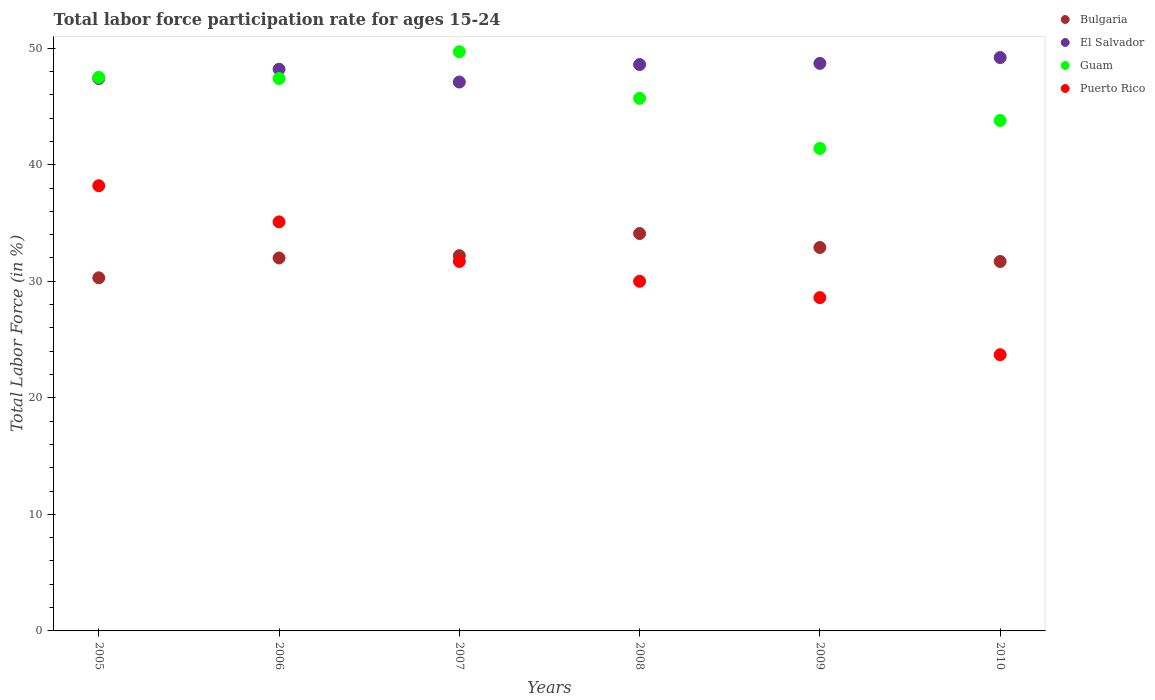How many different coloured dotlines are there?
Provide a succinct answer. 4. Across all years, what is the maximum labor force participation rate in Bulgaria?
Offer a terse response. 34.1. Across all years, what is the minimum labor force participation rate in El Salvador?
Your response must be concise. 47.1. In which year was the labor force participation rate in Bulgaria maximum?
Ensure brevity in your answer.  2008. In which year was the labor force participation rate in El Salvador minimum?
Your answer should be very brief. 2007. What is the total labor force participation rate in Bulgaria in the graph?
Provide a short and direct response. 193.2. What is the difference between the labor force participation rate in Guam in 2006 and that in 2007?
Your answer should be compact. -2.3. What is the difference between the labor force participation rate in Puerto Rico in 2010 and the labor force participation rate in Bulgaria in 2007?
Provide a short and direct response. -8.5. What is the average labor force participation rate in Puerto Rico per year?
Your answer should be very brief. 31.22. In the year 2005, what is the difference between the labor force participation rate in Bulgaria and labor force participation rate in El Salvador?
Make the answer very short. -17.1. In how many years, is the labor force participation rate in El Salvador greater than 16 %?
Your response must be concise. 6. What is the ratio of the labor force participation rate in Guam in 2006 to that in 2010?
Keep it short and to the point. 1.08. Is the labor force participation rate in Puerto Rico in 2007 less than that in 2009?
Your answer should be compact. No. Is the difference between the labor force participation rate in Bulgaria in 2005 and 2006 greater than the difference between the labor force participation rate in El Salvador in 2005 and 2006?
Offer a terse response. No. What is the difference between the highest and the second highest labor force participation rate in El Salvador?
Provide a short and direct response. 0.5. What is the difference between the highest and the lowest labor force participation rate in Guam?
Offer a terse response. 8.3. In how many years, is the labor force participation rate in Puerto Rico greater than the average labor force participation rate in Puerto Rico taken over all years?
Provide a short and direct response. 3. Is the sum of the labor force participation rate in El Salvador in 2008 and 2010 greater than the maximum labor force participation rate in Guam across all years?
Provide a succinct answer. Yes. Is it the case that in every year, the sum of the labor force participation rate in Puerto Rico and labor force participation rate in Guam  is greater than the sum of labor force participation rate in Bulgaria and labor force participation rate in El Salvador?
Your answer should be compact. No. Is it the case that in every year, the sum of the labor force participation rate in Guam and labor force participation rate in Puerto Rico  is greater than the labor force participation rate in Bulgaria?
Offer a terse response. Yes. Is the labor force participation rate in Puerto Rico strictly less than the labor force participation rate in Bulgaria over the years?
Your response must be concise. No. How many dotlines are there?
Your answer should be very brief. 4. What is the difference between two consecutive major ticks on the Y-axis?
Keep it short and to the point. 10. Does the graph contain any zero values?
Provide a succinct answer. No. Does the graph contain grids?
Your answer should be compact. No. What is the title of the graph?
Provide a succinct answer. Total labor force participation rate for ages 15-24. Does "Georgia" appear as one of the legend labels in the graph?
Give a very brief answer. No. What is the label or title of the X-axis?
Provide a short and direct response. Years. What is the label or title of the Y-axis?
Your answer should be very brief. Total Labor Force (in %). What is the Total Labor Force (in %) in Bulgaria in 2005?
Provide a succinct answer. 30.3. What is the Total Labor Force (in %) in El Salvador in 2005?
Offer a very short reply. 47.4. What is the Total Labor Force (in %) of Guam in 2005?
Provide a succinct answer. 47.5. What is the Total Labor Force (in %) in Puerto Rico in 2005?
Offer a very short reply. 38.2. What is the Total Labor Force (in %) of Bulgaria in 2006?
Provide a short and direct response. 32. What is the Total Labor Force (in %) of El Salvador in 2006?
Your response must be concise. 48.2. What is the Total Labor Force (in %) of Guam in 2006?
Give a very brief answer. 47.4. What is the Total Labor Force (in %) in Puerto Rico in 2006?
Give a very brief answer. 35.1. What is the Total Labor Force (in %) in Bulgaria in 2007?
Offer a very short reply. 32.2. What is the Total Labor Force (in %) in El Salvador in 2007?
Make the answer very short. 47.1. What is the Total Labor Force (in %) of Guam in 2007?
Ensure brevity in your answer.  49.7. What is the Total Labor Force (in %) of Puerto Rico in 2007?
Make the answer very short. 31.7. What is the Total Labor Force (in %) in Bulgaria in 2008?
Offer a terse response. 34.1. What is the Total Labor Force (in %) in El Salvador in 2008?
Your answer should be very brief. 48.6. What is the Total Labor Force (in %) of Guam in 2008?
Your answer should be very brief. 45.7. What is the Total Labor Force (in %) in Bulgaria in 2009?
Provide a succinct answer. 32.9. What is the Total Labor Force (in %) of El Salvador in 2009?
Keep it short and to the point. 48.7. What is the Total Labor Force (in %) in Guam in 2009?
Make the answer very short. 41.4. What is the Total Labor Force (in %) in Puerto Rico in 2009?
Your answer should be compact. 28.6. What is the Total Labor Force (in %) of Bulgaria in 2010?
Make the answer very short. 31.7. What is the Total Labor Force (in %) in El Salvador in 2010?
Your response must be concise. 49.2. What is the Total Labor Force (in %) of Guam in 2010?
Offer a very short reply. 43.8. What is the Total Labor Force (in %) in Puerto Rico in 2010?
Your answer should be compact. 23.7. Across all years, what is the maximum Total Labor Force (in %) in Bulgaria?
Your answer should be compact. 34.1. Across all years, what is the maximum Total Labor Force (in %) in El Salvador?
Give a very brief answer. 49.2. Across all years, what is the maximum Total Labor Force (in %) of Guam?
Offer a terse response. 49.7. Across all years, what is the maximum Total Labor Force (in %) of Puerto Rico?
Provide a succinct answer. 38.2. Across all years, what is the minimum Total Labor Force (in %) in Bulgaria?
Provide a short and direct response. 30.3. Across all years, what is the minimum Total Labor Force (in %) of El Salvador?
Keep it short and to the point. 47.1. Across all years, what is the minimum Total Labor Force (in %) in Guam?
Offer a very short reply. 41.4. Across all years, what is the minimum Total Labor Force (in %) of Puerto Rico?
Your answer should be very brief. 23.7. What is the total Total Labor Force (in %) in Bulgaria in the graph?
Offer a very short reply. 193.2. What is the total Total Labor Force (in %) of El Salvador in the graph?
Provide a succinct answer. 289.2. What is the total Total Labor Force (in %) in Guam in the graph?
Give a very brief answer. 275.5. What is the total Total Labor Force (in %) of Puerto Rico in the graph?
Provide a short and direct response. 187.3. What is the difference between the Total Labor Force (in %) of Bulgaria in 2005 and that in 2007?
Provide a succinct answer. -1.9. What is the difference between the Total Labor Force (in %) of Guam in 2005 and that in 2007?
Offer a very short reply. -2.2. What is the difference between the Total Labor Force (in %) in El Salvador in 2005 and that in 2008?
Make the answer very short. -1.2. What is the difference between the Total Labor Force (in %) of Guam in 2005 and that in 2008?
Your answer should be very brief. 1.8. What is the difference between the Total Labor Force (in %) in El Salvador in 2005 and that in 2009?
Your response must be concise. -1.3. What is the difference between the Total Labor Force (in %) of Puerto Rico in 2005 and that in 2009?
Your answer should be compact. 9.6. What is the difference between the Total Labor Force (in %) in Bulgaria in 2005 and that in 2010?
Your response must be concise. -1.4. What is the difference between the Total Labor Force (in %) in Puerto Rico in 2005 and that in 2010?
Give a very brief answer. 14.5. What is the difference between the Total Labor Force (in %) in Bulgaria in 2006 and that in 2007?
Your answer should be compact. -0.2. What is the difference between the Total Labor Force (in %) in Guam in 2006 and that in 2007?
Ensure brevity in your answer.  -2.3. What is the difference between the Total Labor Force (in %) in Puerto Rico in 2006 and that in 2007?
Keep it short and to the point. 3.4. What is the difference between the Total Labor Force (in %) in El Salvador in 2006 and that in 2008?
Make the answer very short. -0.4. What is the difference between the Total Labor Force (in %) in Guam in 2006 and that in 2008?
Make the answer very short. 1.7. What is the difference between the Total Labor Force (in %) in Guam in 2006 and that in 2009?
Provide a succinct answer. 6. What is the difference between the Total Labor Force (in %) in Bulgaria in 2006 and that in 2010?
Your response must be concise. 0.3. What is the difference between the Total Labor Force (in %) in Guam in 2006 and that in 2010?
Ensure brevity in your answer.  3.6. What is the difference between the Total Labor Force (in %) in Puerto Rico in 2006 and that in 2010?
Make the answer very short. 11.4. What is the difference between the Total Labor Force (in %) in Puerto Rico in 2007 and that in 2009?
Give a very brief answer. 3.1. What is the difference between the Total Labor Force (in %) in Guam in 2007 and that in 2010?
Ensure brevity in your answer.  5.9. What is the difference between the Total Labor Force (in %) of Bulgaria in 2008 and that in 2009?
Provide a short and direct response. 1.2. What is the difference between the Total Labor Force (in %) of Guam in 2008 and that in 2009?
Make the answer very short. 4.3. What is the difference between the Total Labor Force (in %) of Guam in 2008 and that in 2010?
Make the answer very short. 1.9. What is the difference between the Total Labor Force (in %) in Puerto Rico in 2008 and that in 2010?
Give a very brief answer. 6.3. What is the difference between the Total Labor Force (in %) of Bulgaria in 2009 and that in 2010?
Offer a very short reply. 1.2. What is the difference between the Total Labor Force (in %) of El Salvador in 2009 and that in 2010?
Offer a very short reply. -0.5. What is the difference between the Total Labor Force (in %) in Guam in 2009 and that in 2010?
Provide a succinct answer. -2.4. What is the difference between the Total Labor Force (in %) of Bulgaria in 2005 and the Total Labor Force (in %) of El Salvador in 2006?
Your answer should be very brief. -17.9. What is the difference between the Total Labor Force (in %) in Bulgaria in 2005 and the Total Labor Force (in %) in Guam in 2006?
Give a very brief answer. -17.1. What is the difference between the Total Labor Force (in %) in El Salvador in 2005 and the Total Labor Force (in %) in Guam in 2006?
Offer a very short reply. 0. What is the difference between the Total Labor Force (in %) in El Salvador in 2005 and the Total Labor Force (in %) in Puerto Rico in 2006?
Offer a very short reply. 12.3. What is the difference between the Total Labor Force (in %) in Guam in 2005 and the Total Labor Force (in %) in Puerto Rico in 2006?
Keep it short and to the point. 12.4. What is the difference between the Total Labor Force (in %) of Bulgaria in 2005 and the Total Labor Force (in %) of El Salvador in 2007?
Provide a short and direct response. -16.8. What is the difference between the Total Labor Force (in %) of Bulgaria in 2005 and the Total Labor Force (in %) of Guam in 2007?
Offer a very short reply. -19.4. What is the difference between the Total Labor Force (in %) of Bulgaria in 2005 and the Total Labor Force (in %) of Puerto Rico in 2007?
Your answer should be very brief. -1.4. What is the difference between the Total Labor Force (in %) in El Salvador in 2005 and the Total Labor Force (in %) in Guam in 2007?
Give a very brief answer. -2.3. What is the difference between the Total Labor Force (in %) of El Salvador in 2005 and the Total Labor Force (in %) of Puerto Rico in 2007?
Your answer should be compact. 15.7. What is the difference between the Total Labor Force (in %) of Guam in 2005 and the Total Labor Force (in %) of Puerto Rico in 2007?
Make the answer very short. 15.8. What is the difference between the Total Labor Force (in %) of Bulgaria in 2005 and the Total Labor Force (in %) of El Salvador in 2008?
Offer a terse response. -18.3. What is the difference between the Total Labor Force (in %) in Bulgaria in 2005 and the Total Labor Force (in %) in Guam in 2008?
Provide a succinct answer. -15.4. What is the difference between the Total Labor Force (in %) in El Salvador in 2005 and the Total Labor Force (in %) in Guam in 2008?
Your answer should be compact. 1.7. What is the difference between the Total Labor Force (in %) in Bulgaria in 2005 and the Total Labor Force (in %) in El Salvador in 2009?
Make the answer very short. -18.4. What is the difference between the Total Labor Force (in %) of Bulgaria in 2005 and the Total Labor Force (in %) of Guam in 2009?
Your answer should be compact. -11.1. What is the difference between the Total Labor Force (in %) of El Salvador in 2005 and the Total Labor Force (in %) of Puerto Rico in 2009?
Keep it short and to the point. 18.8. What is the difference between the Total Labor Force (in %) in Guam in 2005 and the Total Labor Force (in %) in Puerto Rico in 2009?
Offer a terse response. 18.9. What is the difference between the Total Labor Force (in %) of Bulgaria in 2005 and the Total Labor Force (in %) of El Salvador in 2010?
Your response must be concise. -18.9. What is the difference between the Total Labor Force (in %) in Bulgaria in 2005 and the Total Labor Force (in %) in Guam in 2010?
Offer a terse response. -13.5. What is the difference between the Total Labor Force (in %) in Bulgaria in 2005 and the Total Labor Force (in %) in Puerto Rico in 2010?
Make the answer very short. 6.6. What is the difference between the Total Labor Force (in %) of El Salvador in 2005 and the Total Labor Force (in %) of Guam in 2010?
Ensure brevity in your answer.  3.6. What is the difference between the Total Labor Force (in %) in El Salvador in 2005 and the Total Labor Force (in %) in Puerto Rico in 2010?
Your answer should be compact. 23.7. What is the difference between the Total Labor Force (in %) in Guam in 2005 and the Total Labor Force (in %) in Puerto Rico in 2010?
Provide a succinct answer. 23.8. What is the difference between the Total Labor Force (in %) of Bulgaria in 2006 and the Total Labor Force (in %) of El Salvador in 2007?
Offer a very short reply. -15.1. What is the difference between the Total Labor Force (in %) of Bulgaria in 2006 and the Total Labor Force (in %) of Guam in 2007?
Ensure brevity in your answer.  -17.7. What is the difference between the Total Labor Force (in %) in Bulgaria in 2006 and the Total Labor Force (in %) in Puerto Rico in 2007?
Ensure brevity in your answer.  0.3. What is the difference between the Total Labor Force (in %) in El Salvador in 2006 and the Total Labor Force (in %) in Guam in 2007?
Keep it short and to the point. -1.5. What is the difference between the Total Labor Force (in %) of El Salvador in 2006 and the Total Labor Force (in %) of Puerto Rico in 2007?
Provide a short and direct response. 16.5. What is the difference between the Total Labor Force (in %) of Bulgaria in 2006 and the Total Labor Force (in %) of El Salvador in 2008?
Provide a succinct answer. -16.6. What is the difference between the Total Labor Force (in %) in Bulgaria in 2006 and the Total Labor Force (in %) in Guam in 2008?
Keep it short and to the point. -13.7. What is the difference between the Total Labor Force (in %) in Bulgaria in 2006 and the Total Labor Force (in %) in Puerto Rico in 2008?
Offer a very short reply. 2. What is the difference between the Total Labor Force (in %) of El Salvador in 2006 and the Total Labor Force (in %) of Guam in 2008?
Your response must be concise. 2.5. What is the difference between the Total Labor Force (in %) of El Salvador in 2006 and the Total Labor Force (in %) of Puerto Rico in 2008?
Give a very brief answer. 18.2. What is the difference between the Total Labor Force (in %) of Bulgaria in 2006 and the Total Labor Force (in %) of El Salvador in 2009?
Ensure brevity in your answer.  -16.7. What is the difference between the Total Labor Force (in %) in Bulgaria in 2006 and the Total Labor Force (in %) in Guam in 2009?
Your answer should be very brief. -9.4. What is the difference between the Total Labor Force (in %) in Bulgaria in 2006 and the Total Labor Force (in %) in Puerto Rico in 2009?
Keep it short and to the point. 3.4. What is the difference between the Total Labor Force (in %) in El Salvador in 2006 and the Total Labor Force (in %) in Guam in 2009?
Give a very brief answer. 6.8. What is the difference between the Total Labor Force (in %) in El Salvador in 2006 and the Total Labor Force (in %) in Puerto Rico in 2009?
Your response must be concise. 19.6. What is the difference between the Total Labor Force (in %) in Bulgaria in 2006 and the Total Labor Force (in %) in El Salvador in 2010?
Offer a very short reply. -17.2. What is the difference between the Total Labor Force (in %) in Guam in 2006 and the Total Labor Force (in %) in Puerto Rico in 2010?
Provide a short and direct response. 23.7. What is the difference between the Total Labor Force (in %) in Bulgaria in 2007 and the Total Labor Force (in %) in El Salvador in 2008?
Your answer should be very brief. -16.4. What is the difference between the Total Labor Force (in %) in Bulgaria in 2007 and the Total Labor Force (in %) in Puerto Rico in 2008?
Keep it short and to the point. 2.2. What is the difference between the Total Labor Force (in %) in El Salvador in 2007 and the Total Labor Force (in %) in Guam in 2008?
Your answer should be compact. 1.4. What is the difference between the Total Labor Force (in %) in El Salvador in 2007 and the Total Labor Force (in %) in Puerto Rico in 2008?
Make the answer very short. 17.1. What is the difference between the Total Labor Force (in %) of Guam in 2007 and the Total Labor Force (in %) of Puerto Rico in 2008?
Your answer should be compact. 19.7. What is the difference between the Total Labor Force (in %) of Bulgaria in 2007 and the Total Labor Force (in %) of El Salvador in 2009?
Make the answer very short. -16.5. What is the difference between the Total Labor Force (in %) of El Salvador in 2007 and the Total Labor Force (in %) of Puerto Rico in 2009?
Your response must be concise. 18.5. What is the difference between the Total Labor Force (in %) in Guam in 2007 and the Total Labor Force (in %) in Puerto Rico in 2009?
Your answer should be very brief. 21.1. What is the difference between the Total Labor Force (in %) of Bulgaria in 2007 and the Total Labor Force (in %) of El Salvador in 2010?
Your answer should be compact. -17. What is the difference between the Total Labor Force (in %) in Bulgaria in 2007 and the Total Labor Force (in %) in Guam in 2010?
Your answer should be very brief. -11.6. What is the difference between the Total Labor Force (in %) of El Salvador in 2007 and the Total Labor Force (in %) of Guam in 2010?
Offer a very short reply. 3.3. What is the difference between the Total Labor Force (in %) in El Salvador in 2007 and the Total Labor Force (in %) in Puerto Rico in 2010?
Your response must be concise. 23.4. What is the difference between the Total Labor Force (in %) of Bulgaria in 2008 and the Total Labor Force (in %) of El Salvador in 2009?
Make the answer very short. -14.6. What is the difference between the Total Labor Force (in %) of Bulgaria in 2008 and the Total Labor Force (in %) of Guam in 2009?
Your answer should be very brief. -7.3. What is the difference between the Total Labor Force (in %) in Bulgaria in 2008 and the Total Labor Force (in %) in Puerto Rico in 2009?
Your answer should be very brief. 5.5. What is the difference between the Total Labor Force (in %) in Guam in 2008 and the Total Labor Force (in %) in Puerto Rico in 2009?
Your response must be concise. 17.1. What is the difference between the Total Labor Force (in %) in Bulgaria in 2008 and the Total Labor Force (in %) in El Salvador in 2010?
Offer a terse response. -15.1. What is the difference between the Total Labor Force (in %) of El Salvador in 2008 and the Total Labor Force (in %) of Guam in 2010?
Offer a very short reply. 4.8. What is the difference between the Total Labor Force (in %) in El Salvador in 2008 and the Total Labor Force (in %) in Puerto Rico in 2010?
Your answer should be compact. 24.9. What is the difference between the Total Labor Force (in %) of Bulgaria in 2009 and the Total Labor Force (in %) of El Salvador in 2010?
Give a very brief answer. -16.3. What is the difference between the Total Labor Force (in %) of Bulgaria in 2009 and the Total Labor Force (in %) of Puerto Rico in 2010?
Keep it short and to the point. 9.2. What is the difference between the Total Labor Force (in %) in El Salvador in 2009 and the Total Labor Force (in %) in Guam in 2010?
Ensure brevity in your answer.  4.9. What is the difference between the Total Labor Force (in %) in El Salvador in 2009 and the Total Labor Force (in %) in Puerto Rico in 2010?
Keep it short and to the point. 25. What is the average Total Labor Force (in %) of Bulgaria per year?
Provide a short and direct response. 32.2. What is the average Total Labor Force (in %) in El Salvador per year?
Offer a very short reply. 48.2. What is the average Total Labor Force (in %) in Guam per year?
Ensure brevity in your answer.  45.92. What is the average Total Labor Force (in %) in Puerto Rico per year?
Make the answer very short. 31.22. In the year 2005, what is the difference between the Total Labor Force (in %) of Bulgaria and Total Labor Force (in %) of El Salvador?
Your response must be concise. -17.1. In the year 2005, what is the difference between the Total Labor Force (in %) in Bulgaria and Total Labor Force (in %) in Guam?
Your answer should be compact. -17.2. In the year 2005, what is the difference between the Total Labor Force (in %) in El Salvador and Total Labor Force (in %) in Guam?
Ensure brevity in your answer.  -0.1. In the year 2005, what is the difference between the Total Labor Force (in %) of El Salvador and Total Labor Force (in %) of Puerto Rico?
Ensure brevity in your answer.  9.2. In the year 2006, what is the difference between the Total Labor Force (in %) of Bulgaria and Total Labor Force (in %) of El Salvador?
Ensure brevity in your answer.  -16.2. In the year 2006, what is the difference between the Total Labor Force (in %) of Bulgaria and Total Labor Force (in %) of Guam?
Provide a succinct answer. -15.4. In the year 2006, what is the difference between the Total Labor Force (in %) in Bulgaria and Total Labor Force (in %) in Puerto Rico?
Offer a terse response. -3.1. In the year 2006, what is the difference between the Total Labor Force (in %) of El Salvador and Total Labor Force (in %) of Puerto Rico?
Keep it short and to the point. 13.1. In the year 2007, what is the difference between the Total Labor Force (in %) of Bulgaria and Total Labor Force (in %) of El Salvador?
Offer a very short reply. -14.9. In the year 2007, what is the difference between the Total Labor Force (in %) in Bulgaria and Total Labor Force (in %) in Guam?
Provide a succinct answer. -17.5. In the year 2007, what is the difference between the Total Labor Force (in %) in El Salvador and Total Labor Force (in %) in Guam?
Provide a short and direct response. -2.6. In the year 2007, what is the difference between the Total Labor Force (in %) in Guam and Total Labor Force (in %) in Puerto Rico?
Make the answer very short. 18. In the year 2008, what is the difference between the Total Labor Force (in %) of El Salvador and Total Labor Force (in %) of Guam?
Give a very brief answer. 2.9. In the year 2008, what is the difference between the Total Labor Force (in %) in El Salvador and Total Labor Force (in %) in Puerto Rico?
Provide a short and direct response. 18.6. In the year 2009, what is the difference between the Total Labor Force (in %) of Bulgaria and Total Labor Force (in %) of El Salvador?
Your answer should be very brief. -15.8. In the year 2009, what is the difference between the Total Labor Force (in %) of El Salvador and Total Labor Force (in %) of Guam?
Ensure brevity in your answer.  7.3. In the year 2009, what is the difference between the Total Labor Force (in %) in El Salvador and Total Labor Force (in %) in Puerto Rico?
Your answer should be compact. 20.1. In the year 2009, what is the difference between the Total Labor Force (in %) in Guam and Total Labor Force (in %) in Puerto Rico?
Give a very brief answer. 12.8. In the year 2010, what is the difference between the Total Labor Force (in %) in Bulgaria and Total Labor Force (in %) in El Salvador?
Offer a very short reply. -17.5. In the year 2010, what is the difference between the Total Labor Force (in %) of Bulgaria and Total Labor Force (in %) of Puerto Rico?
Make the answer very short. 8. In the year 2010, what is the difference between the Total Labor Force (in %) in Guam and Total Labor Force (in %) in Puerto Rico?
Offer a very short reply. 20.1. What is the ratio of the Total Labor Force (in %) in Bulgaria in 2005 to that in 2006?
Provide a succinct answer. 0.95. What is the ratio of the Total Labor Force (in %) in El Salvador in 2005 to that in 2006?
Provide a succinct answer. 0.98. What is the ratio of the Total Labor Force (in %) in Guam in 2005 to that in 2006?
Make the answer very short. 1. What is the ratio of the Total Labor Force (in %) of Puerto Rico in 2005 to that in 2006?
Offer a very short reply. 1.09. What is the ratio of the Total Labor Force (in %) in Bulgaria in 2005 to that in 2007?
Offer a terse response. 0.94. What is the ratio of the Total Labor Force (in %) of El Salvador in 2005 to that in 2007?
Offer a very short reply. 1.01. What is the ratio of the Total Labor Force (in %) in Guam in 2005 to that in 2007?
Make the answer very short. 0.96. What is the ratio of the Total Labor Force (in %) in Puerto Rico in 2005 to that in 2007?
Provide a short and direct response. 1.21. What is the ratio of the Total Labor Force (in %) of Bulgaria in 2005 to that in 2008?
Give a very brief answer. 0.89. What is the ratio of the Total Labor Force (in %) in El Salvador in 2005 to that in 2008?
Your response must be concise. 0.98. What is the ratio of the Total Labor Force (in %) of Guam in 2005 to that in 2008?
Your answer should be compact. 1.04. What is the ratio of the Total Labor Force (in %) of Puerto Rico in 2005 to that in 2008?
Keep it short and to the point. 1.27. What is the ratio of the Total Labor Force (in %) in Bulgaria in 2005 to that in 2009?
Keep it short and to the point. 0.92. What is the ratio of the Total Labor Force (in %) in El Salvador in 2005 to that in 2009?
Give a very brief answer. 0.97. What is the ratio of the Total Labor Force (in %) of Guam in 2005 to that in 2009?
Offer a terse response. 1.15. What is the ratio of the Total Labor Force (in %) in Puerto Rico in 2005 to that in 2009?
Your response must be concise. 1.34. What is the ratio of the Total Labor Force (in %) of Bulgaria in 2005 to that in 2010?
Keep it short and to the point. 0.96. What is the ratio of the Total Labor Force (in %) in El Salvador in 2005 to that in 2010?
Offer a very short reply. 0.96. What is the ratio of the Total Labor Force (in %) in Guam in 2005 to that in 2010?
Offer a very short reply. 1.08. What is the ratio of the Total Labor Force (in %) in Puerto Rico in 2005 to that in 2010?
Make the answer very short. 1.61. What is the ratio of the Total Labor Force (in %) of El Salvador in 2006 to that in 2007?
Your answer should be compact. 1.02. What is the ratio of the Total Labor Force (in %) of Guam in 2006 to that in 2007?
Your response must be concise. 0.95. What is the ratio of the Total Labor Force (in %) in Puerto Rico in 2006 to that in 2007?
Your answer should be compact. 1.11. What is the ratio of the Total Labor Force (in %) in Bulgaria in 2006 to that in 2008?
Keep it short and to the point. 0.94. What is the ratio of the Total Labor Force (in %) in El Salvador in 2006 to that in 2008?
Give a very brief answer. 0.99. What is the ratio of the Total Labor Force (in %) of Guam in 2006 to that in 2008?
Make the answer very short. 1.04. What is the ratio of the Total Labor Force (in %) in Puerto Rico in 2006 to that in 2008?
Keep it short and to the point. 1.17. What is the ratio of the Total Labor Force (in %) in Bulgaria in 2006 to that in 2009?
Keep it short and to the point. 0.97. What is the ratio of the Total Labor Force (in %) in Guam in 2006 to that in 2009?
Your response must be concise. 1.14. What is the ratio of the Total Labor Force (in %) in Puerto Rico in 2006 to that in 2009?
Give a very brief answer. 1.23. What is the ratio of the Total Labor Force (in %) of Bulgaria in 2006 to that in 2010?
Provide a succinct answer. 1.01. What is the ratio of the Total Labor Force (in %) of El Salvador in 2006 to that in 2010?
Your answer should be compact. 0.98. What is the ratio of the Total Labor Force (in %) of Guam in 2006 to that in 2010?
Offer a terse response. 1.08. What is the ratio of the Total Labor Force (in %) in Puerto Rico in 2006 to that in 2010?
Your answer should be very brief. 1.48. What is the ratio of the Total Labor Force (in %) of Bulgaria in 2007 to that in 2008?
Ensure brevity in your answer.  0.94. What is the ratio of the Total Labor Force (in %) in El Salvador in 2007 to that in 2008?
Make the answer very short. 0.97. What is the ratio of the Total Labor Force (in %) of Guam in 2007 to that in 2008?
Your answer should be very brief. 1.09. What is the ratio of the Total Labor Force (in %) of Puerto Rico in 2007 to that in 2008?
Provide a short and direct response. 1.06. What is the ratio of the Total Labor Force (in %) in Bulgaria in 2007 to that in 2009?
Keep it short and to the point. 0.98. What is the ratio of the Total Labor Force (in %) of El Salvador in 2007 to that in 2009?
Your answer should be compact. 0.97. What is the ratio of the Total Labor Force (in %) in Guam in 2007 to that in 2009?
Ensure brevity in your answer.  1.2. What is the ratio of the Total Labor Force (in %) in Puerto Rico in 2007 to that in 2009?
Ensure brevity in your answer.  1.11. What is the ratio of the Total Labor Force (in %) in Bulgaria in 2007 to that in 2010?
Provide a short and direct response. 1.02. What is the ratio of the Total Labor Force (in %) of El Salvador in 2007 to that in 2010?
Make the answer very short. 0.96. What is the ratio of the Total Labor Force (in %) in Guam in 2007 to that in 2010?
Your response must be concise. 1.13. What is the ratio of the Total Labor Force (in %) of Puerto Rico in 2007 to that in 2010?
Your answer should be very brief. 1.34. What is the ratio of the Total Labor Force (in %) in Bulgaria in 2008 to that in 2009?
Make the answer very short. 1.04. What is the ratio of the Total Labor Force (in %) in Guam in 2008 to that in 2009?
Provide a short and direct response. 1.1. What is the ratio of the Total Labor Force (in %) in Puerto Rico in 2008 to that in 2009?
Your answer should be compact. 1.05. What is the ratio of the Total Labor Force (in %) in Bulgaria in 2008 to that in 2010?
Give a very brief answer. 1.08. What is the ratio of the Total Labor Force (in %) of Guam in 2008 to that in 2010?
Your answer should be very brief. 1.04. What is the ratio of the Total Labor Force (in %) of Puerto Rico in 2008 to that in 2010?
Your answer should be compact. 1.27. What is the ratio of the Total Labor Force (in %) in Bulgaria in 2009 to that in 2010?
Keep it short and to the point. 1.04. What is the ratio of the Total Labor Force (in %) in El Salvador in 2009 to that in 2010?
Provide a short and direct response. 0.99. What is the ratio of the Total Labor Force (in %) of Guam in 2009 to that in 2010?
Make the answer very short. 0.95. What is the ratio of the Total Labor Force (in %) in Puerto Rico in 2009 to that in 2010?
Provide a succinct answer. 1.21. What is the difference between the highest and the second highest Total Labor Force (in %) of Bulgaria?
Offer a terse response. 1.2. What is the difference between the highest and the second highest Total Labor Force (in %) in El Salvador?
Make the answer very short. 0.5. What is the difference between the highest and the second highest Total Labor Force (in %) of Guam?
Give a very brief answer. 2.2. What is the difference between the highest and the second highest Total Labor Force (in %) in Puerto Rico?
Your response must be concise. 3.1. What is the difference between the highest and the lowest Total Labor Force (in %) in El Salvador?
Your answer should be very brief. 2.1. 